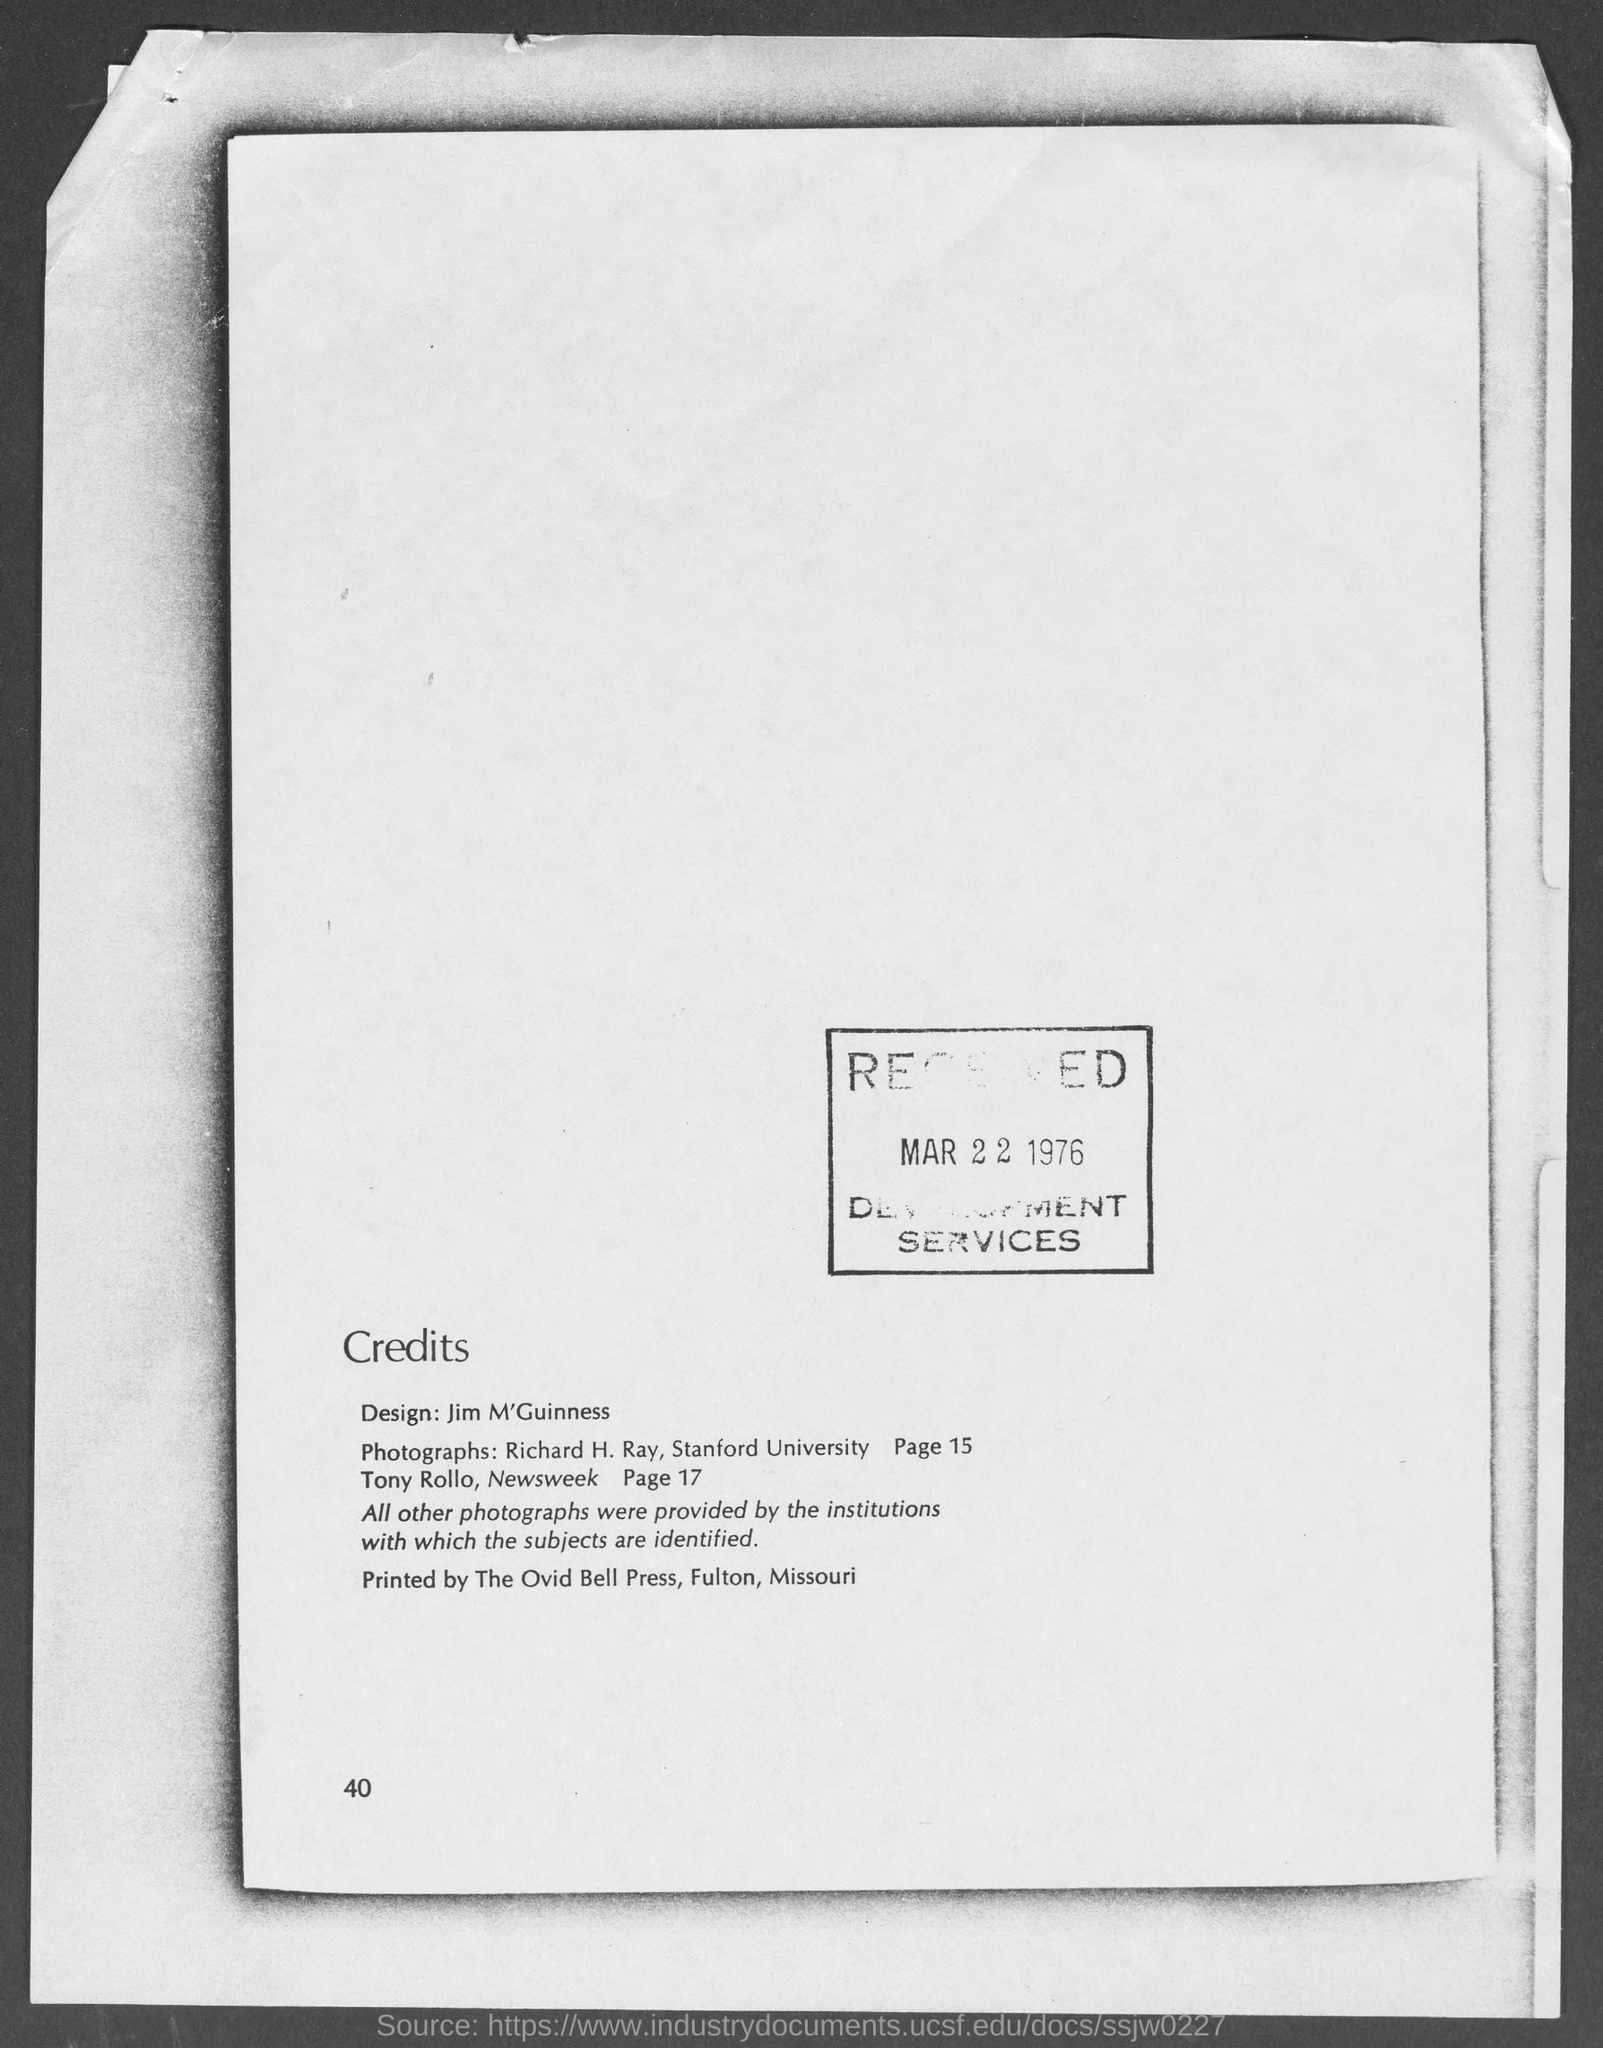What is the page number at bottom of the page?
Make the answer very short. 40. 